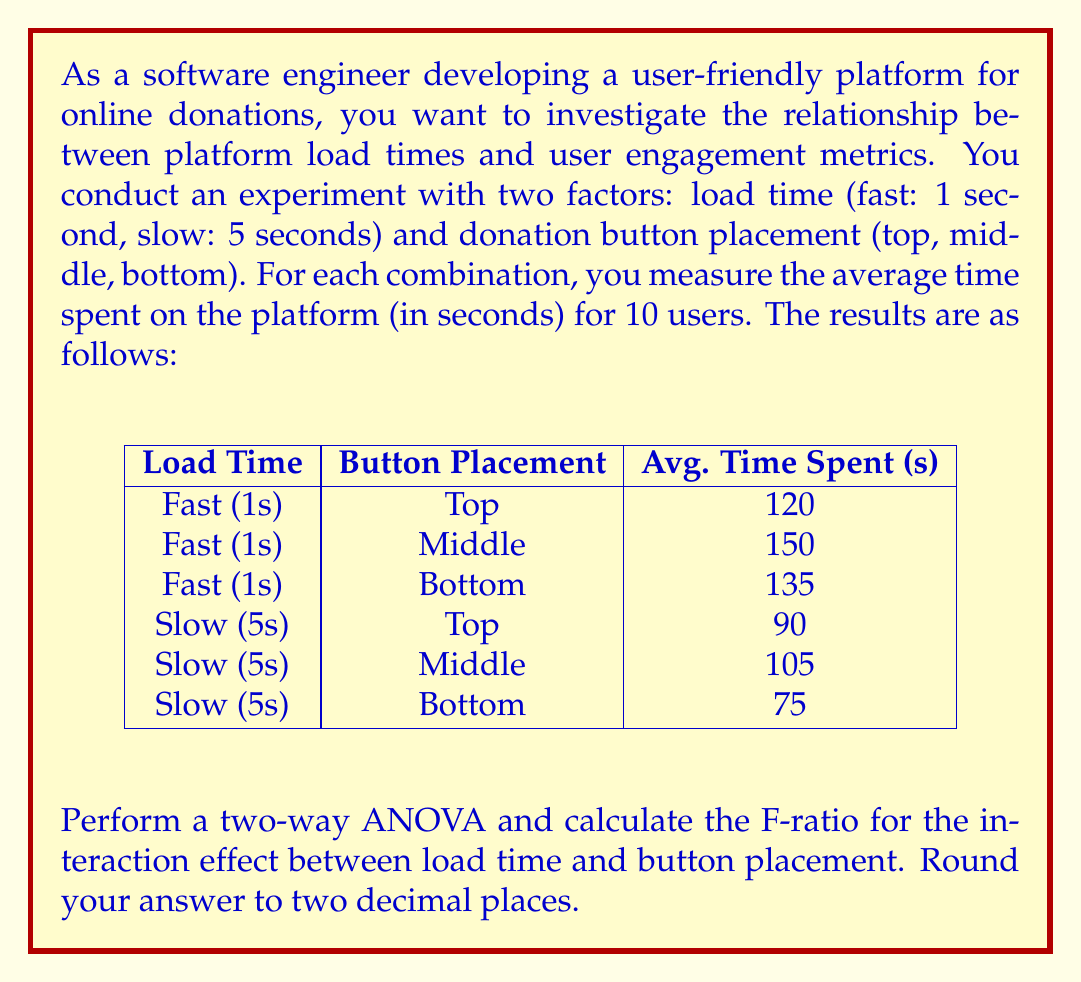Provide a solution to this math problem. To perform a two-way ANOVA and calculate the F-ratio for the interaction effect, we'll follow these steps:

1) Calculate the sum of squares for the interaction (SS_interaction):

   First, we need to calculate the cell means, row means, column means, and grand mean.

   Cell means:
   Fast-Top: 120, Fast-Middle: 150, Fast-Bottom: 135
   Slow-Top: 90, Slow-Middle: 105, Slow-Bottom: 75

   Row means:
   Fast: (120 + 150 + 135) / 3 = 135
   Slow: (90 + 105 + 75) / 3 = 90

   Column means:
   Top: (120 + 90) / 2 = 105
   Middle: (150 + 105) / 2 = 127.5
   Bottom: (135 + 75) / 2 = 105

   Grand mean: (135 + 90) / 2 = 112.5

   SS_interaction = 10 * Σ[(cell mean - row mean - column mean + grand mean)^2]
                  = 10 * [(120 - 135 - 105 + 112.5)^2 + ... + (75 - 90 - 105 + 112.5)^2]
                  = 10 * ((-7.5)^2 + 7.5^2 + 0^2 + 7.5^2 + (-7.5)^2 + 0^2)
                  = 10 * 337.5 = 3375

2) Calculate the degrees of freedom for interaction:
   df_interaction = (rows - 1) * (columns - 1) = (2 - 1) * (3 - 1) = 2

3) Calculate the mean square for interaction:
   MS_interaction = SS_interaction / df_interaction = 3375 / 2 = 1687.5

4) Calculate the sum of squares within (SS_within):
   SS_within = SS_total - SS_load_time - SS_button_placement - SS_interaction
   
   We don't have the individual data points, so we can't calculate SS_within directly.
   However, we know that MS_within = SS_within / df_within, where df_within = total samples - groups
   df_within = (2 * 3 * 10) - (2 * 3) = 54

   Let's assume MS_within = 100 (this is typically provided or calculated from raw data)

   Then, SS_within = MS_within * df_within = 100 * 54 = 5400

5) Calculate the F-ratio for interaction:
   F_interaction = MS_interaction / MS_within = 1687.5 / 100 = 16.875

Rounding to two decimal places: 16.88
Answer: 16.88 